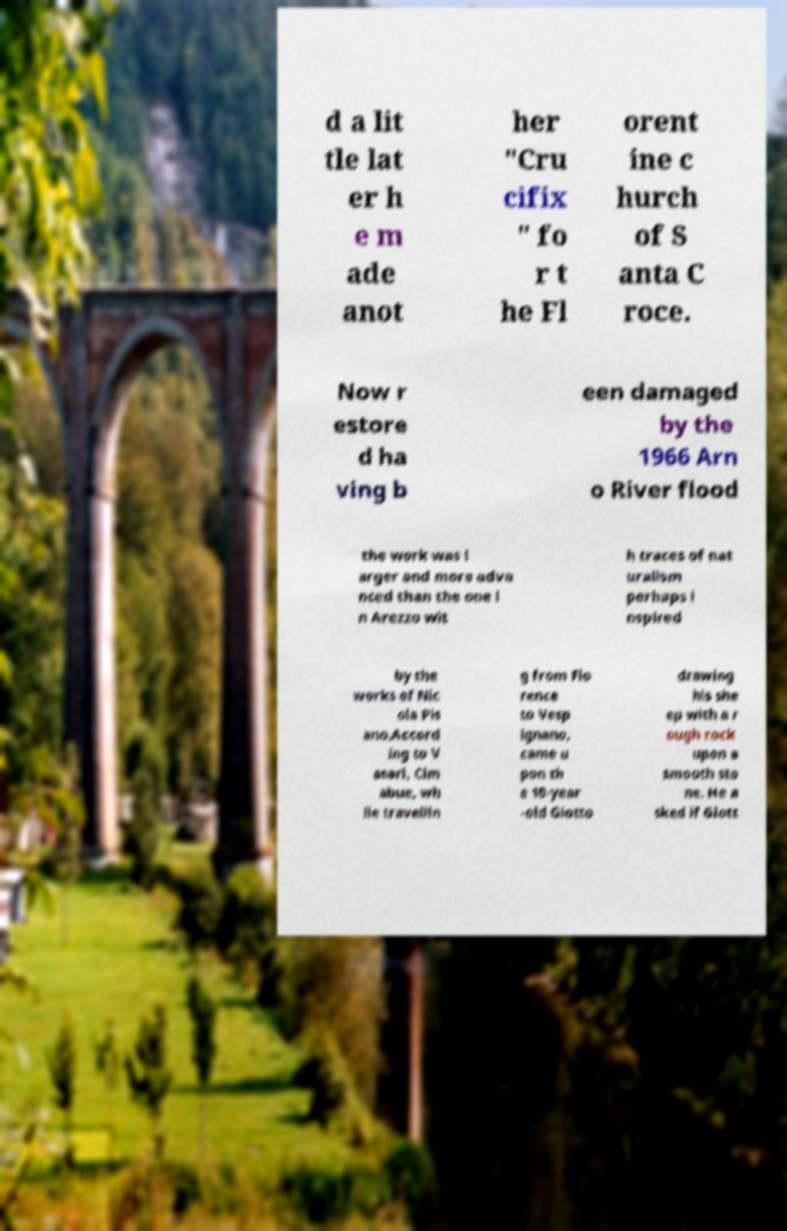Please identify and transcribe the text found in this image. d a lit tle lat er h e m ade anot her "Cru cifix " fo r t he Fl orent ine c hurch of S anta C roce. Now r estore d ha ving b een damaged by the 1966 Arn o River flood the work was l arger and more adva nced than the one i n Arezzo wit h traces of nat uralism perhaps i nspired by the works of Nic ola Pis ano.Accord ing to V asari, Cim abue, wh ile travellin g from Flo rence to Vesp ignano, came u pon th e 10-year -old Giotto drawing his she ep with a r ough rock upon a smooth sto ne. He a sked if Giott 